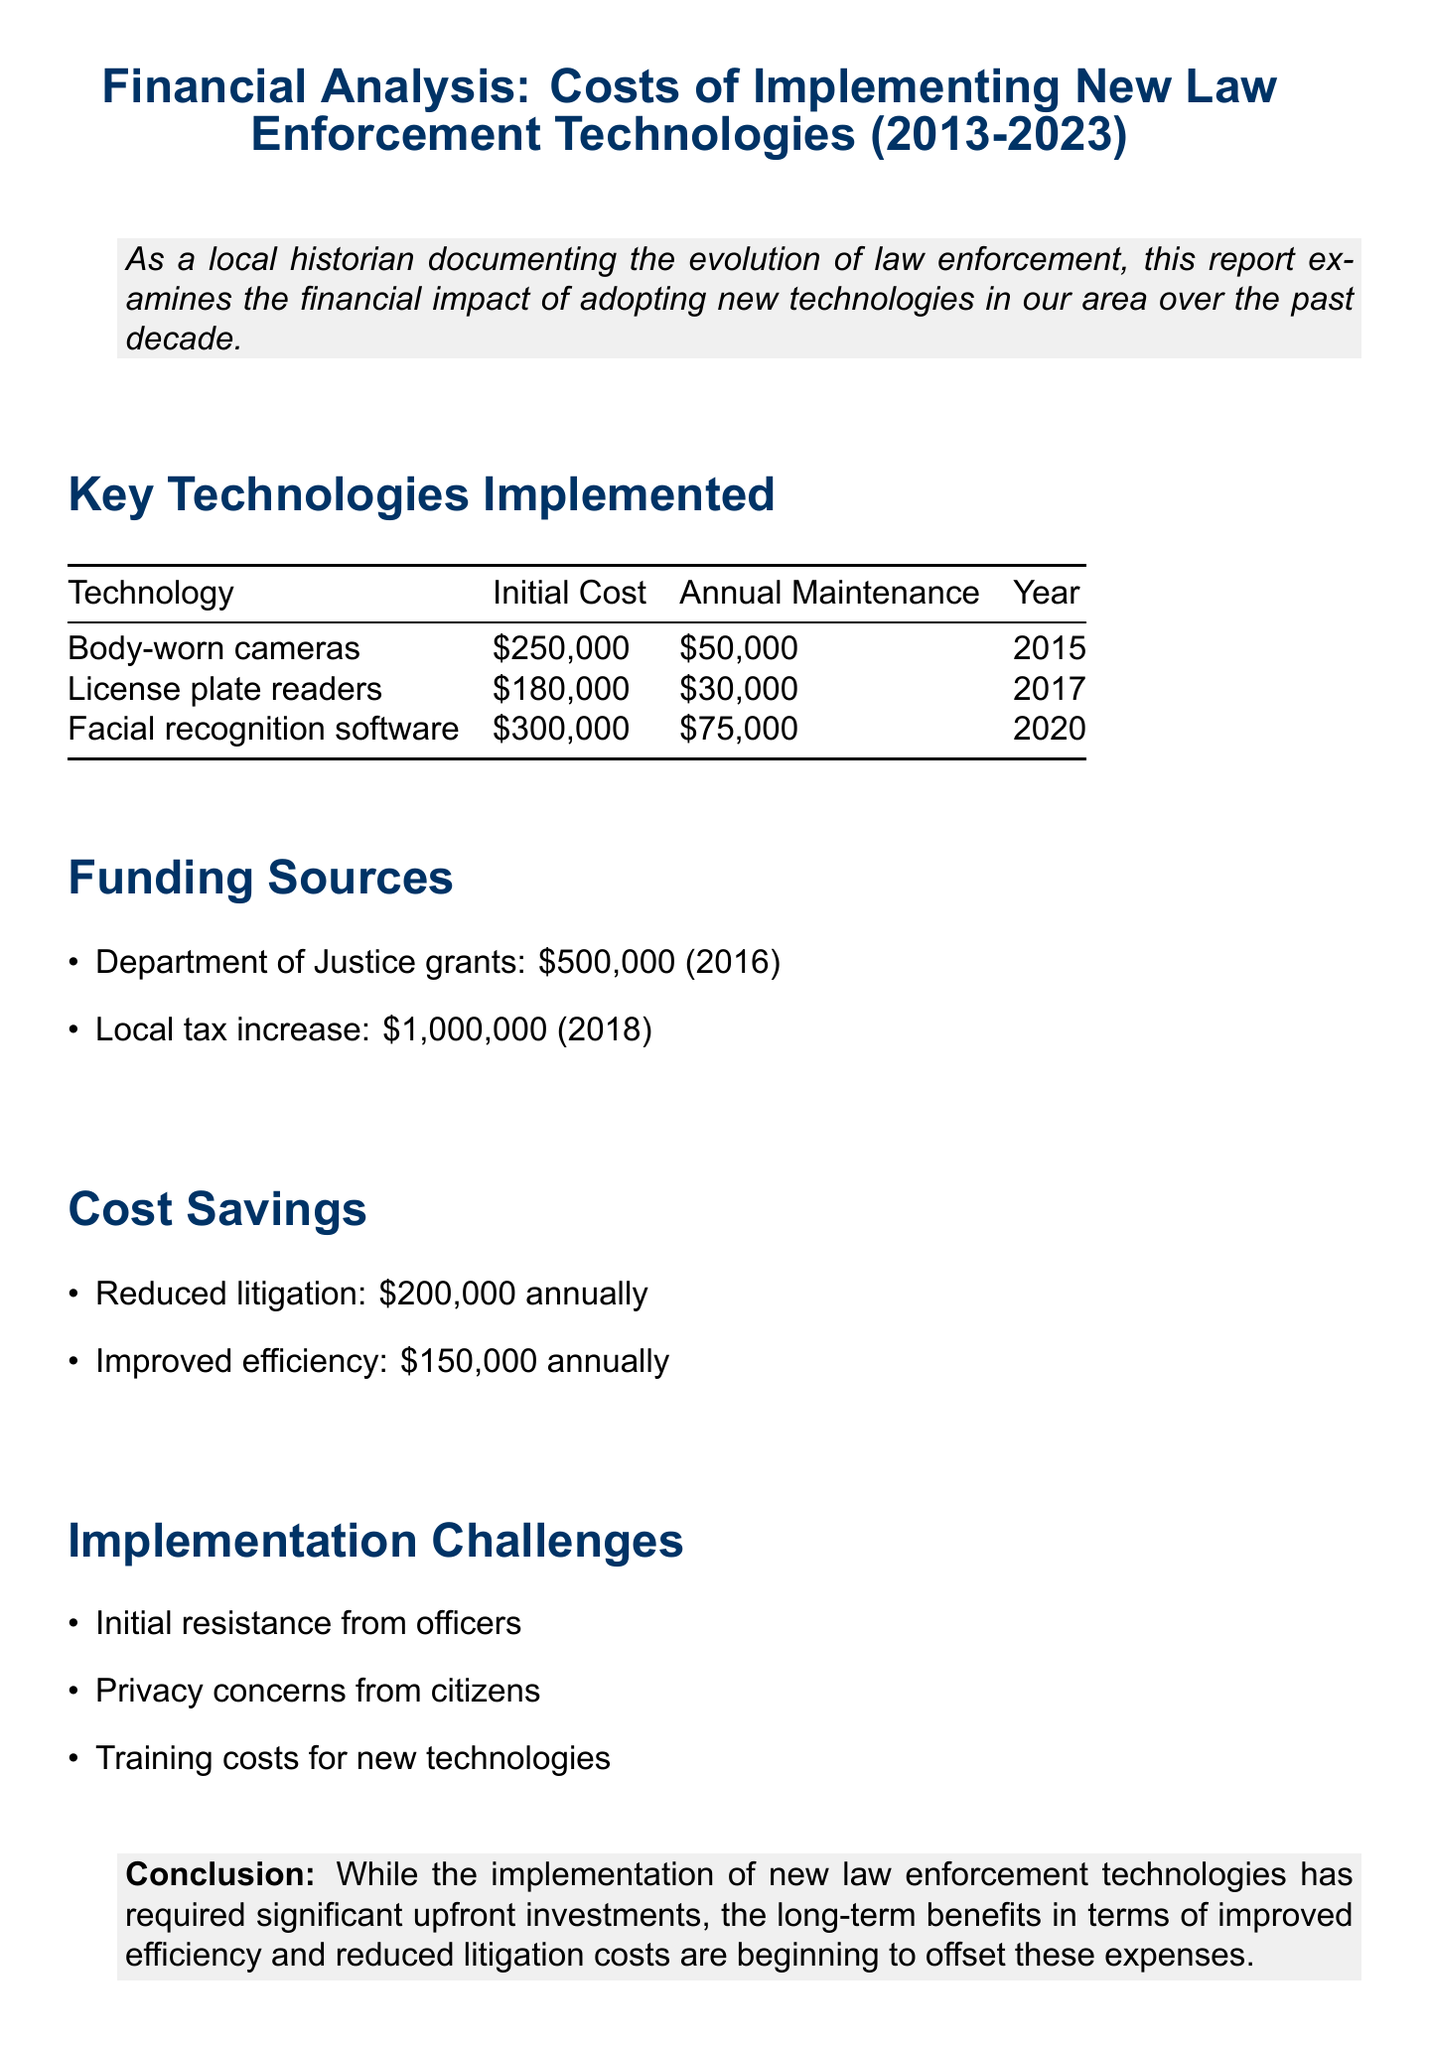What was the initial cost of body-worn cameras? The initial cost of body-worn cameras is specifically stated in the document.
Answer: $250,000 In which year was facial recognition software implemented? The document lists the year each technology was implemented.
Answer: 2020 What are the annual maintenance costs for license plate readers? The document provides annual maintenance costs for each technology.
Answer: $30,000 How much funding did the local tax increase provide in 2018? The specific amount provided by the local tax increase is detailed in the funding sources section.
Answer: $1,000,000 What are the total annual cost savings from reduced litigation and improved efficiency? The total annual cost savings can be calculated by adding the amounts listed in the cost savings section.
Answer: $350,000 What challenge involves citizen concerns? The document lists multiple challenges, and one specifically relates to citizens.
Answer: Privacy concerns from citizens Which grant provided funding in 2016? The funding sources section mentions specific grants along with their years.
Answer: Department of Justice grants What was the total initial investment for all listed technologies? To find the total initial investment, sum the initial costs of all the technologies mentioned.
Answer: $730,000 